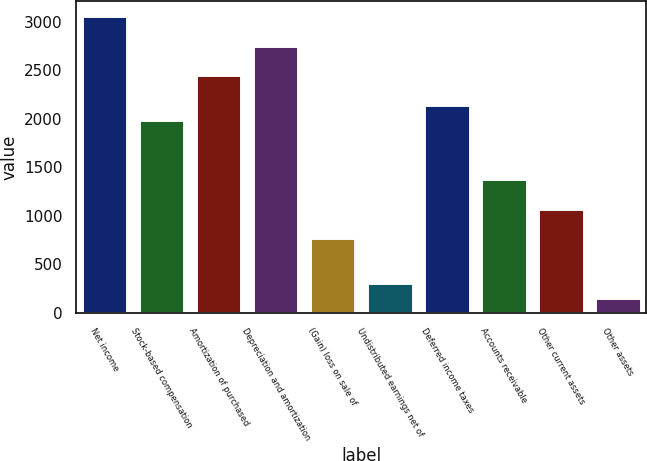<chart> <loc_0><loc_0><loc_500><loc_500><bar_chart><fcel>Net income<fcel>Stock-based compensation<fcel>Amortization of purchased<fcel>Depreciation and amortization<fcel>(Gain) loss on sale of<fcel>Undistributed earnings net of<fcel>Deferred income taxes<fcel>Accounts receivable<fcel>Other current assets<fcel>Other assets<nl><fcel>3061.1<fcel>1991.08<fcel>2449.66<fcel>2755.38<fcel>768.2<fcel>309.62<fcel>2143.94<fcel>1379.64<fcel>1073.92<fcel>156.76<nl></chart> 